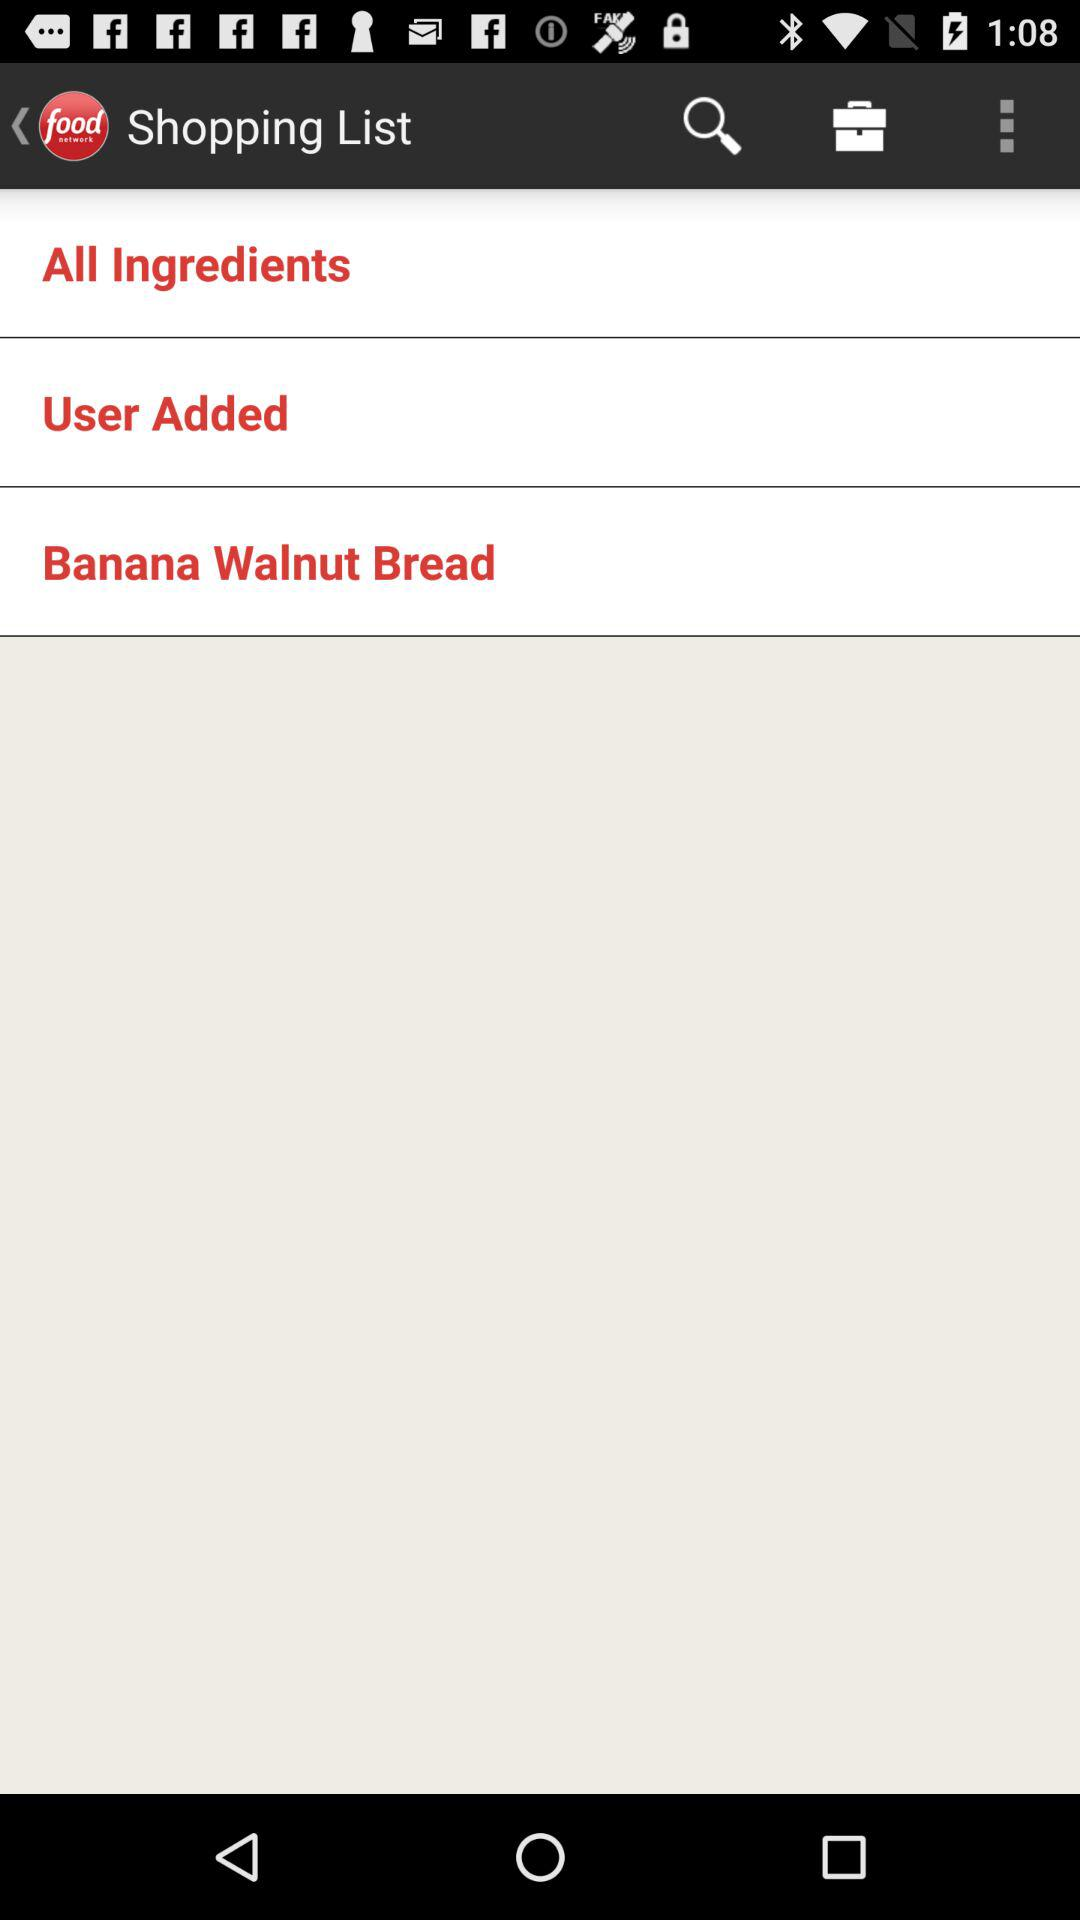What is the application name? The application name is "food network". 